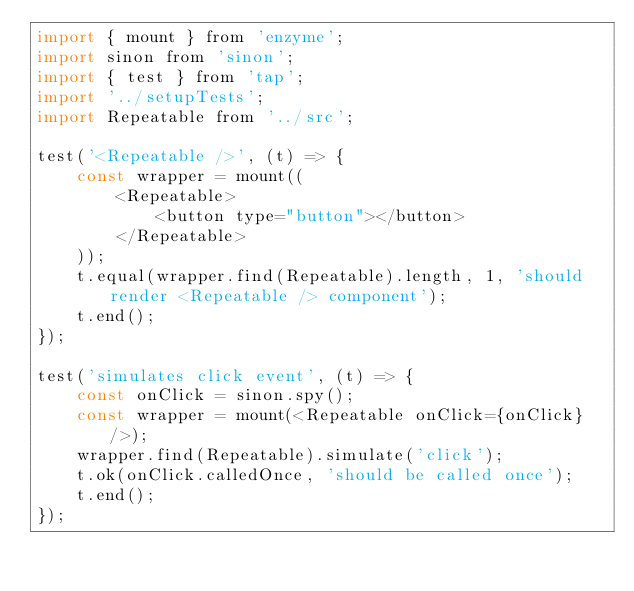Convert code to text. <code><loc_0><loc_0><loc_500><loc_500><_JavaScript_>import { mount } from 'enzyme';
import sinon from 'sinon';
import { test } from 'tap';
import '../setupTests';
import Repeatable from '../src';

test('<Repeatable />', (t) => {
    const wrapper = mount((
        <Repeatable>
            <button type="button"></button>
        </Repeatable>
    ));
    t.equal(wrapper.find(Repeatable).length, 1, 'should render <Repeatable /> component');
    t.end();
});

test('simulates click event', (t) => {
    const onClick = sinon.spy();
    const wrapper = mount(<Repeatable onClick={onClick} />);
    wrapper.find(Repeatable).simulate('click');
    t.ok(onClick.calledOnce, 'should be called once');
    t.end();
});
</code> 